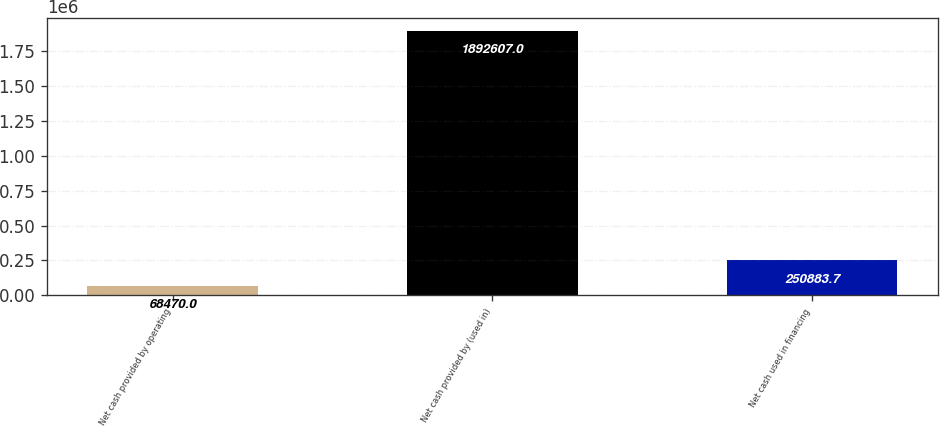Convert chart to OTSL. <chart><loc_0><loc_0><loc_500><loc_500><bar_chart><fcel>Net cash provided by operating<fcel>Net cash provided by (used in)<fcel>Net cash used in financing<nl><fcel>68470<fcel>1.89261e+06<fcel>250884<nl></chart> 